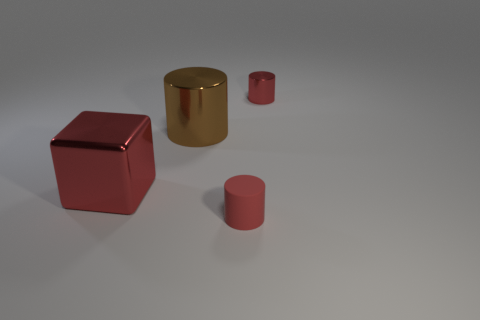Subtract all red cylinders. Subtract all brown blocks. How many cylinders are left? 1 Add 2 big brown shiny things. How many objects exist? 6 Subtract all cylinders. How many objects are left? 1 Add 2 cyan metal balls. How many cyan metal balls exist? 2 Subtract 0 cyan blocks. How many objects are left? 4 Subtract all tiny cyan matte cylinders. Subtract all brown metallic cylinders. How many objects are left? 3 Add 2 tiny objects. How many tiny objects are left? 4 